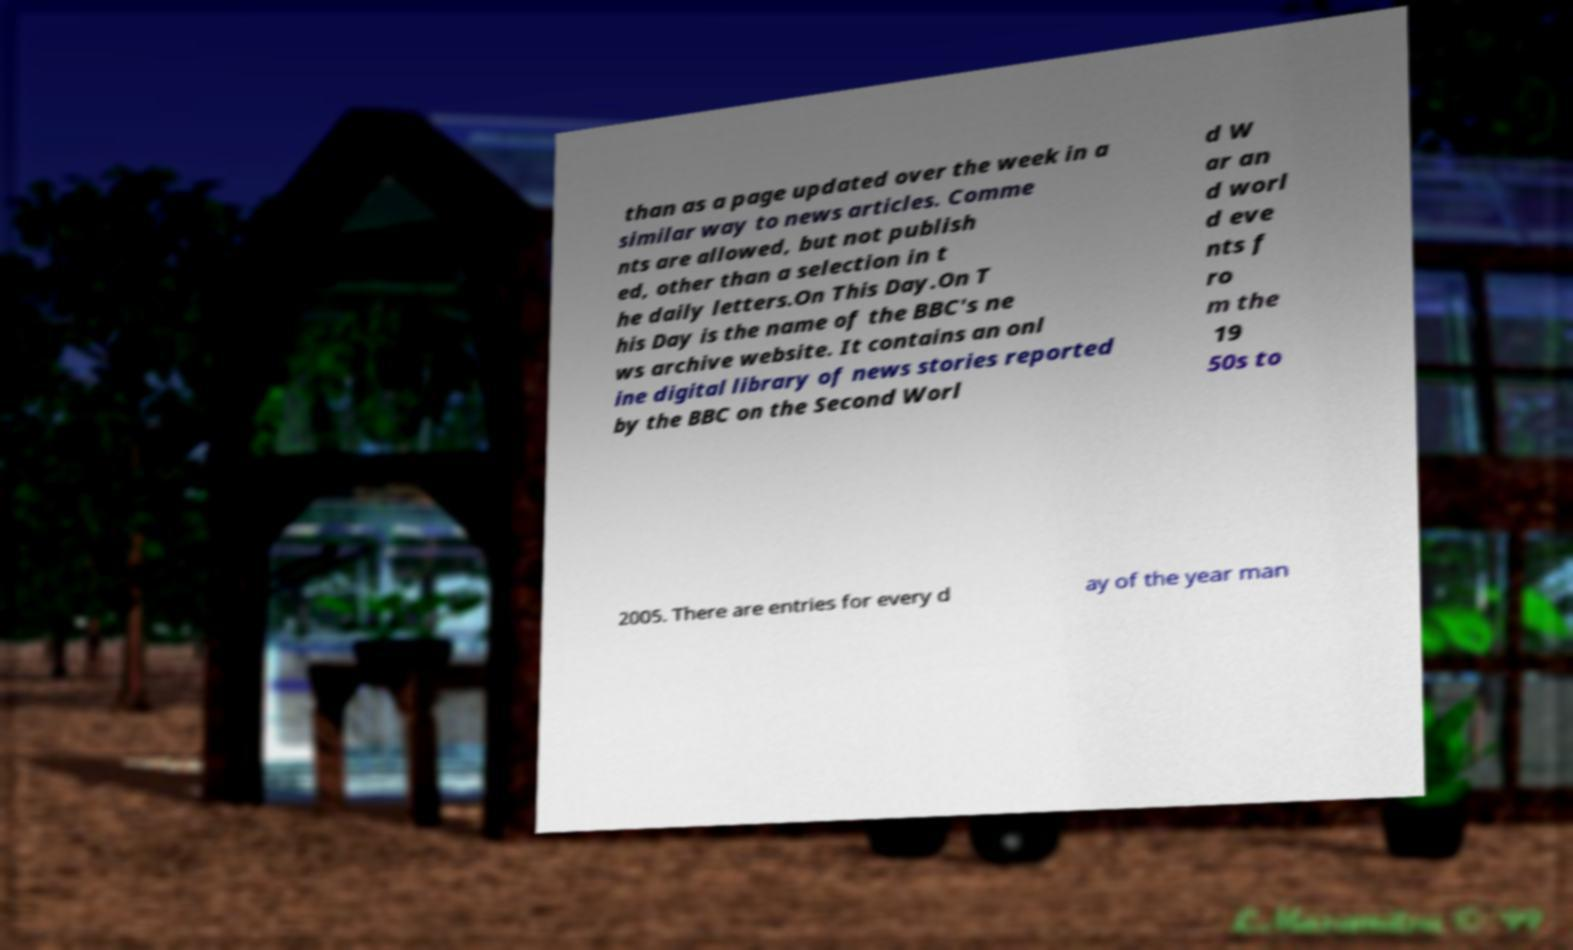Can you accurately transcribe the text from the provided image for me? than as a page updated over the week in a similar way to news articles. Comme nts are allowed, but not publish ed, other than a selection in t he daily letters.On This Day.On T his Day is the name of the BBC's ne ws archive website. It contains an onl ine digital library of news stories reported by the BBC on the Second Worl d W ar an d worl d eve nts f ro m the 19 50s to 2005. There are entries for every d ay of the year man 